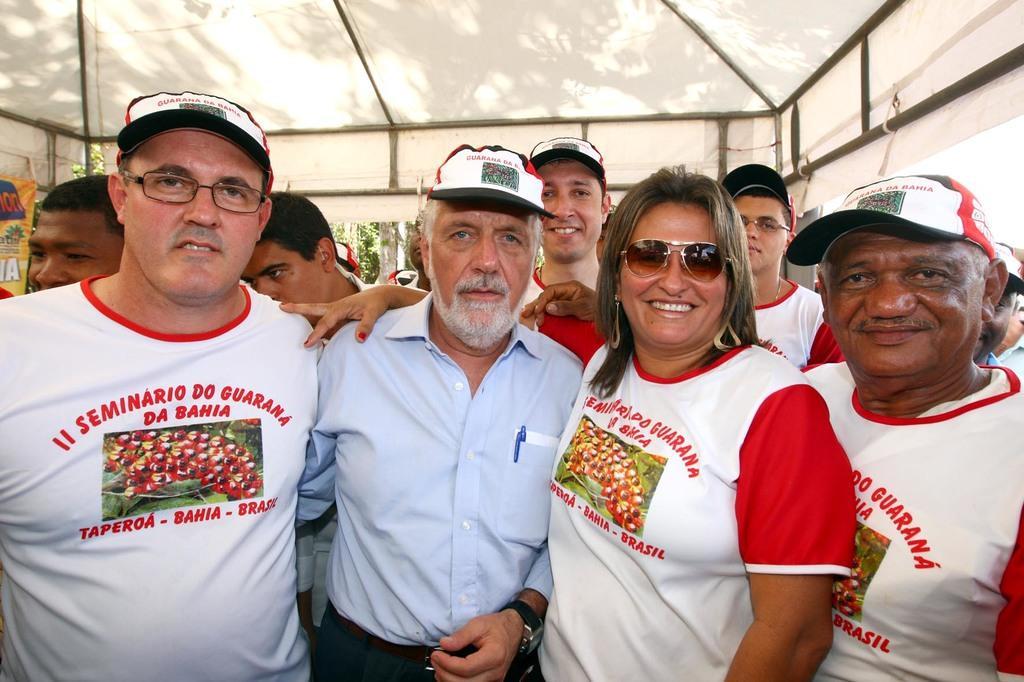Describe this image in one or two sentences. In the picture I can see a group of people are standing among them some are wearing glasses and some are wearing hats. In the background I can see metal rods and some other objects. 